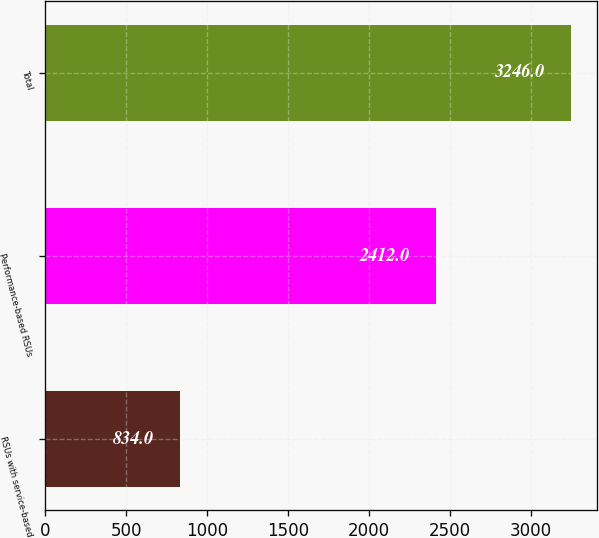Convert chart to OTSL. <chart><loc_0><loc_0><loc_500><loc_500><bar_chart><fcel>RSUs with service-based<fcel>Performance-based RSUs<fcel>Total<nl><fcel>834<fcel>2412<fcel>3246<nl></chart> 